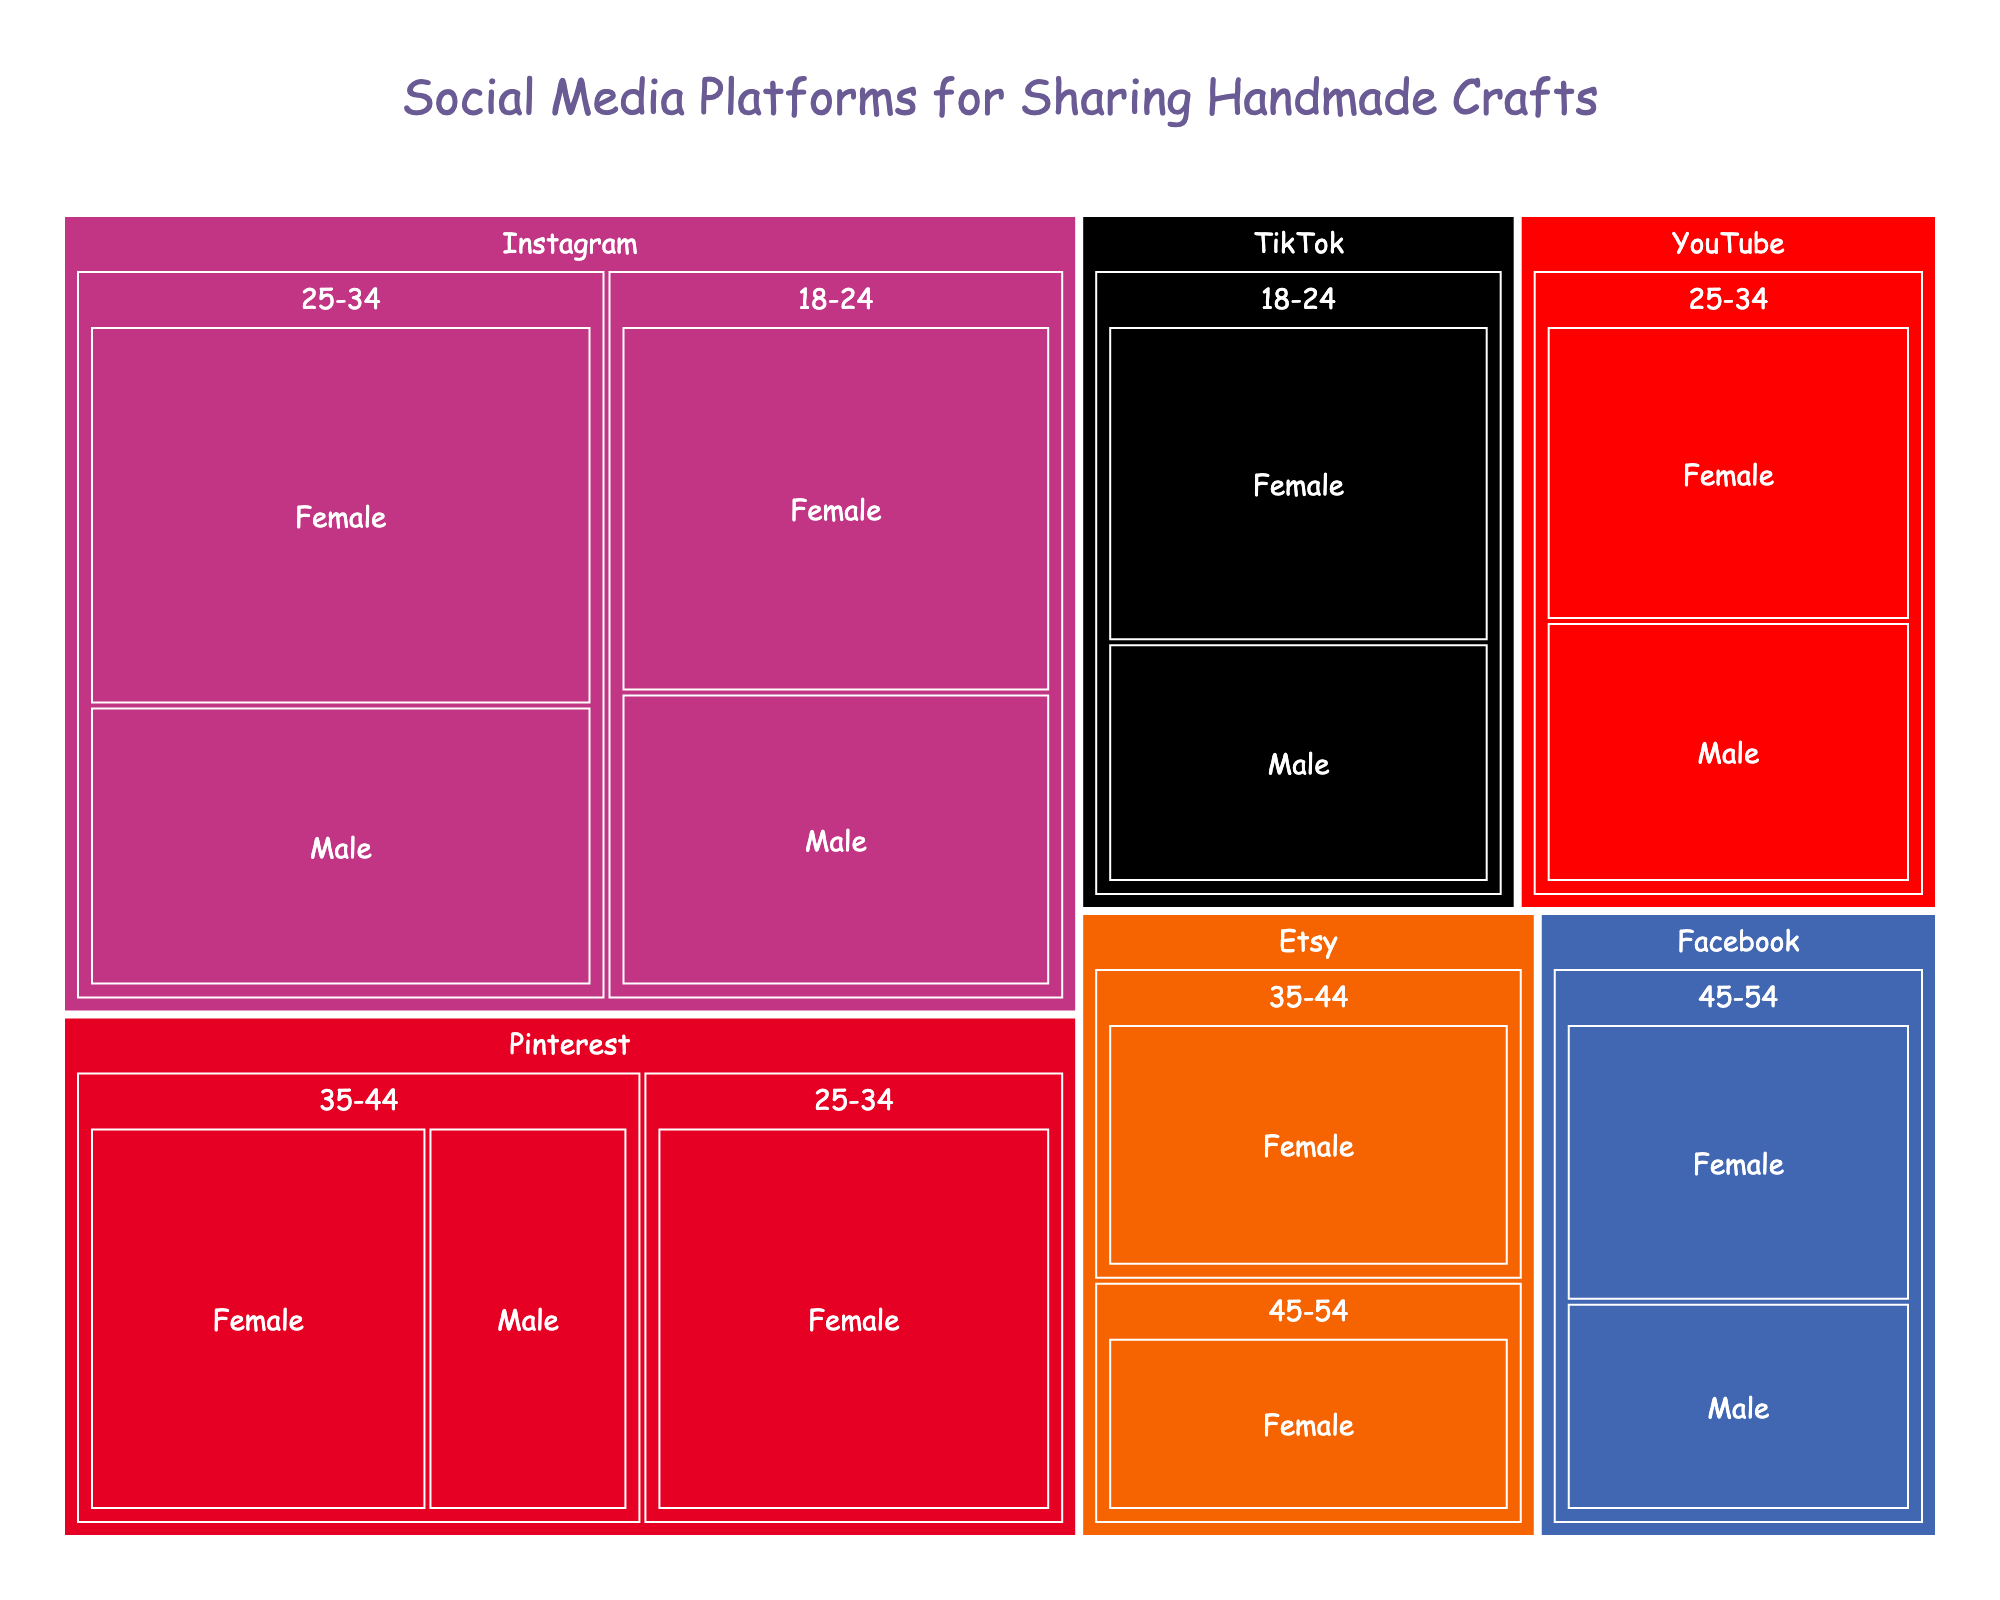What is the title of the treemap? The title is displayed at the top of the treemap in a larger font. It is "Social Media Platforms for Sharing Handmade Crafts".
Answer: Social Media Platforms for Sharing Handmade Crafts Which platform has the largest number of users in the 25-34 age group? By looking at the size of the rectangles in the treemap, you can see that Instagram has the largest number of users in the 25-34 age group.
Answer: Instagram How many users does Pinterest have in the 35-44 age group? Locate Pinterest in the treemap and then find the '35-44' age group. Add up the users for both females and males: 3200 (Female) + 1900 (Male) = 5100 users.
Answer: 5100 Between Facebook and Etsy, which platform has more users in the 45-54 age group, and by how much? Compare the sizes of rectangles or find the exact numbers for both platforms in the 45-54 age group. Facebook has 4200 users (2400 Female + 1800 Male) and Etsy has 2100 users. The difference is 4200 - 2100 = 2100 users.
Answer: Facebook by 2100 users Which gender uses Instagram more in the 18-24 age group? Observe the sizes of the rectangles under Instagram for the 18-24 age group. Females have 3500 users, and males have 2800 users.
Answer: Female What is the sum of users on TikTok and YouTube in the 18-24 and 25-34 age groups? Add up the users for TikTok in 18-24 (2900 Female + 2200 Male) and YouTube in 25-34 (2600 Female + 2300 Male). Total = 2900 + 2200 + 2600 + 2300 = 10000 users.
Answer: 10000 Which platform has the smallest number of users and in which demographic? Find the smallest rectangle in the treemap. The smallest number of users is Pinterest for males aged 35-44, with 1900 users.
Answer: Pinterest, 35-44, Male Compare the total number of female users of Instagram and Pinterest. Which platform has more, and by how much? For Instagram: 3500 (18-24) + 4200 (25-34) = 7700. For Pinterest: 3800 (25-34) + 3200 (35-44) = 7000. Instagram has 7700 - 7000 = 700 more female users than Pinterest.
Answer: Instagram by 700 users What is the proportion of males and females using TikTok in the 18-24 age group? TikTok has 2900 female users and 2200 male users in the 18-24 age group. The total is 5100 users. Proportion for females: 2900 / 5100 * 100 ≈ 56.9%, and for males: 2200 / 5100 * 100 ≈ 43.1%.
Answer: 56.9% Female, 43.1% Male Which social media platform specifically targets older adults (45-54 age group) the most effectively? Observe which platform has the largest rectangle size in the 45-54 age group. Facebook has the highest number of users in this age group with a total of 4200 users.
Answer: Facebook 